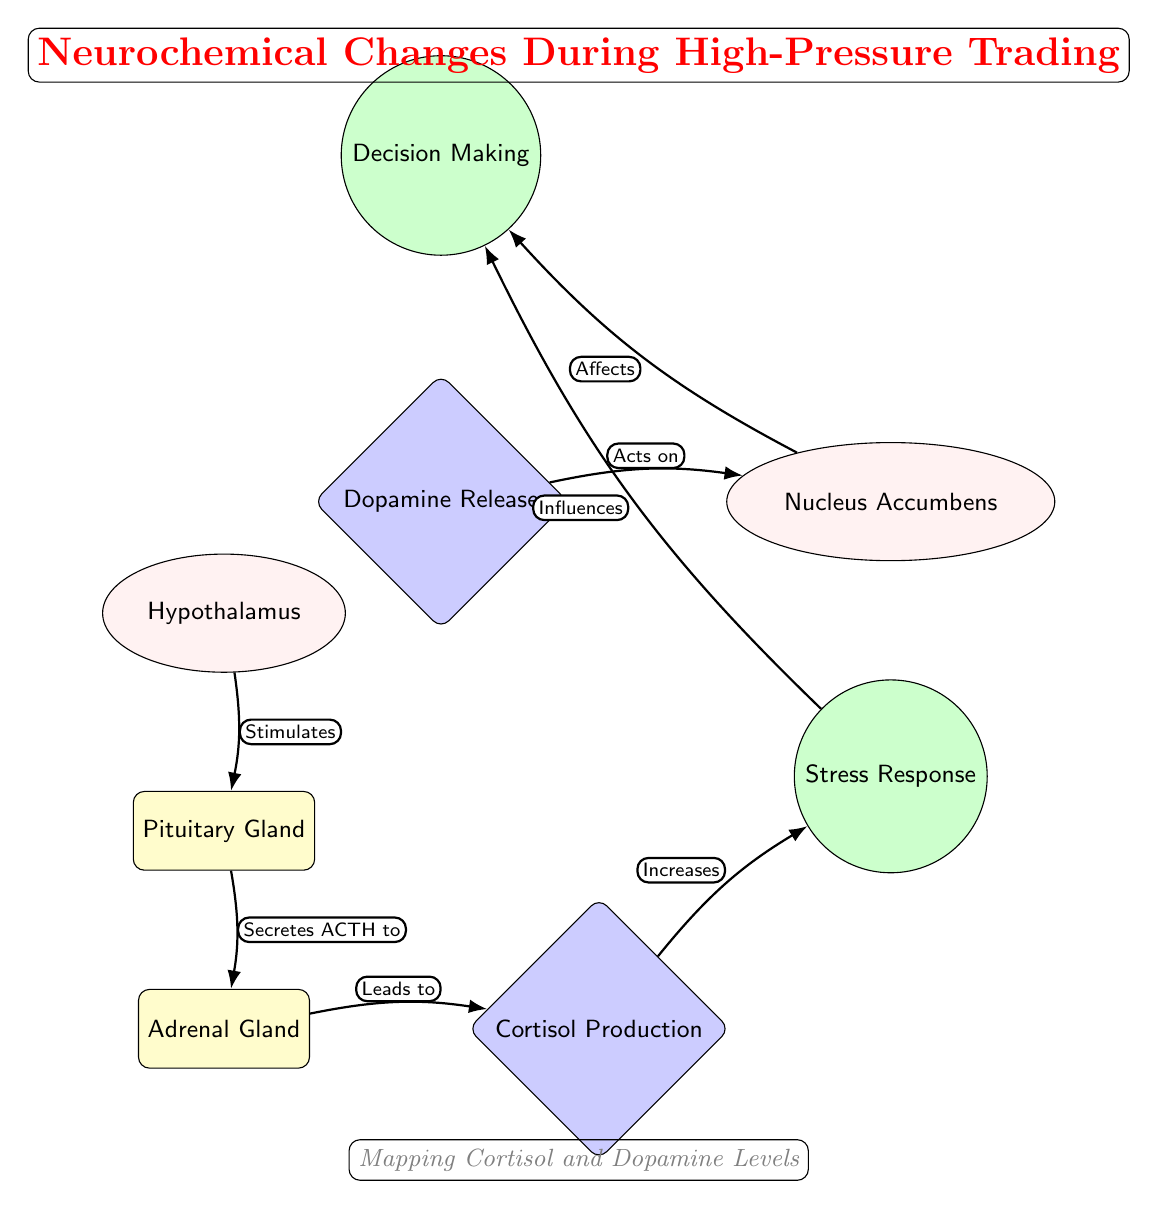What part of the brain stimulates the pituitary gland? The diagram indicates that the Hypothalamus is the part of the brain that stimulates the pituitary gland, as indicated by the edge connecting them labeled with "Stimulates."
Answer: Hypothalamus What hormone does the pituitary gland secrete to the adrenal gland? According to the diagram, the Pituitary Gland secretes ACTH to the Adrenal Gland, which is shown on the edge connecting these nodes labeled "Secretes ACTH to."
Answer: ACTH How many glands are represented in the diagram? The diagram contains two glands: the Pituitary Gland and the Adrenal Gland, both visually represented and connected to the brain's regulatory process.
Answer: 2 What is the effect of cortisol production? The diagram indicates that cortisol production leads to an increase in the stress response, as shown by the connection labeled "Leads to."
Answer: Stress Response What influences decision-making in high-pressure trading? Evaluation of the diagram reveals that both the stress response and dopamine release influence decision-making, as there are arrows pointing to the decision-making node from both the stress and dopamine nodes.
Answer: Stress Response and Dopamine Release What does the Nucleus Accumbens affect? The diagram specifies that the Nucleus Accumbens affects decision-making, which is indicated by the arrow labeled "Affects."
Answer: Decision Making How is dopamine released related to decision-making? Analyzing the diagram shows that dopamine release acts on the Nucleus Accumbens, which subsequently affects decision-making, thus establishing a direct relationship between these processes through the flow of arrows.
Answer: Acts on Nucleus Accumbens Which gland is responsible for cortisol production? The diagram indicates that cortisol production is linked to the Adrenal Gland, as indicated by the flow from the Adrenal Gland to the cortisol production node.
Answer: Adrenal Gland 